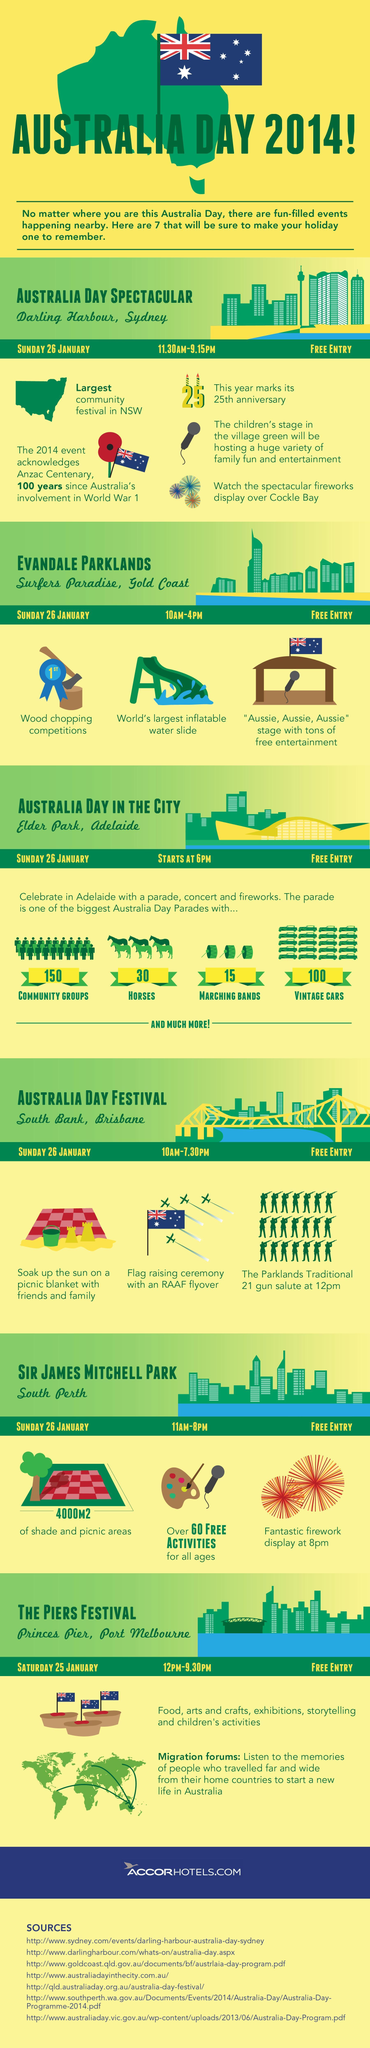How many Marching Bands will be present in the Australia Day parade?
Answer the question with a short phrase. 15 How many events have been organised in the Sir James Mitchell Park South Perth?? 3 How many Vintage Cars will be present in the Australia Day parade? 100 How many Community Groups will be present in the Australia Day parade? 150 How many events have been organised in the Surfers Paradise, Gold Coast? 3 Where the Parklands traditional 21 gun salute event is happening? South Bank, Brisbane How many Horses have been arranged in the Australia Day parade? 30 